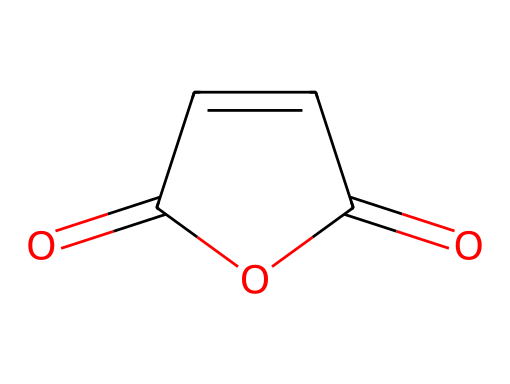What is the name of this chemical? The chemical structure represents maleic anhydride, which can be identified by looking for specific functional groups and the arrangement of atoms.
Answer: maleic anhydride How many carbon atoms are in this molecule? By examining the SMILES representation, there are four carbon atoms (C) in the main structure of maleic anhydride.
Answer: 4 What type of functional groups are present in maleic anhydride? The visual structure indicates the presence of anhydride functional groups, shown by the carbonyl (C=O) connections adjacent to the ring.
Answer: anhydride What is the total number of bonds in this chemical structure? Counting the single and double bonds in the SMILES, there are a total of six bonds in maleic anhydride (2 double bonds and 4 single bonds).
Answer: 6 What is the degree of unsaturation in this molecule? The presence of multiple double bonds indicates a higher degree of unsaturation. Here, there are two double bonds contributing to an unsaturation count of two.
Answer: 2 Can maleic anhydride participate in hydrolysis? Yes, maleic anhydride can undergo hydrolysis because it contains reactive carbonyl groups, which are characteristic of acid anhydrides that react with water.
Answer: yes 